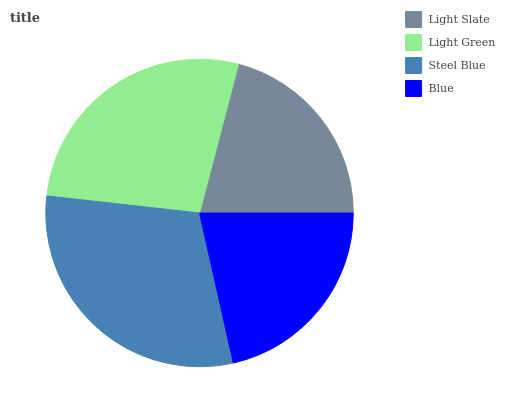Is Light Slate the minimum?
Answer yes or no. Yes. Is Steel Blue the maximum?
Answer yes or no. Yes. Is Light Green the minimum?
Answer yes or no. No. Is Light Green the maximum?
Answer yes or no. No. Is Light Green greater than Light Slate?
Answer yes or no. Yes. Is Light Slate less than Light Green?
Answer yes or no. Yes. Is Light Slate greater than Light Green?
Answer yes or no. No. Is Light Green less than Light Slate?
Answer yes or no. No. Is Light Green the high median?
Answer yes or no. Yes. Is Blue the low median?
Answer yes or no. Yes. Is Steel Blue the high median?
Answer yes or no. No. Is Light Green the low median?
Answer yes or no. No. 